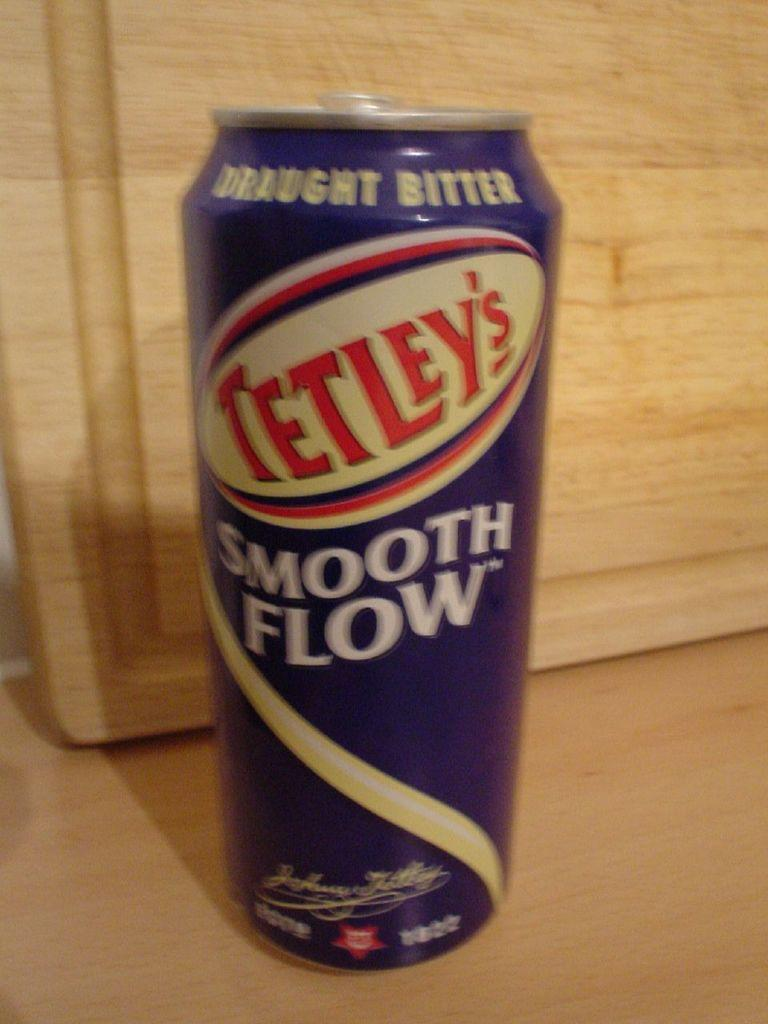Provide a one-sentence caption for the provided image. A can of Tetley's draught bitter sits next to a wooden cutting board that is propped up. 